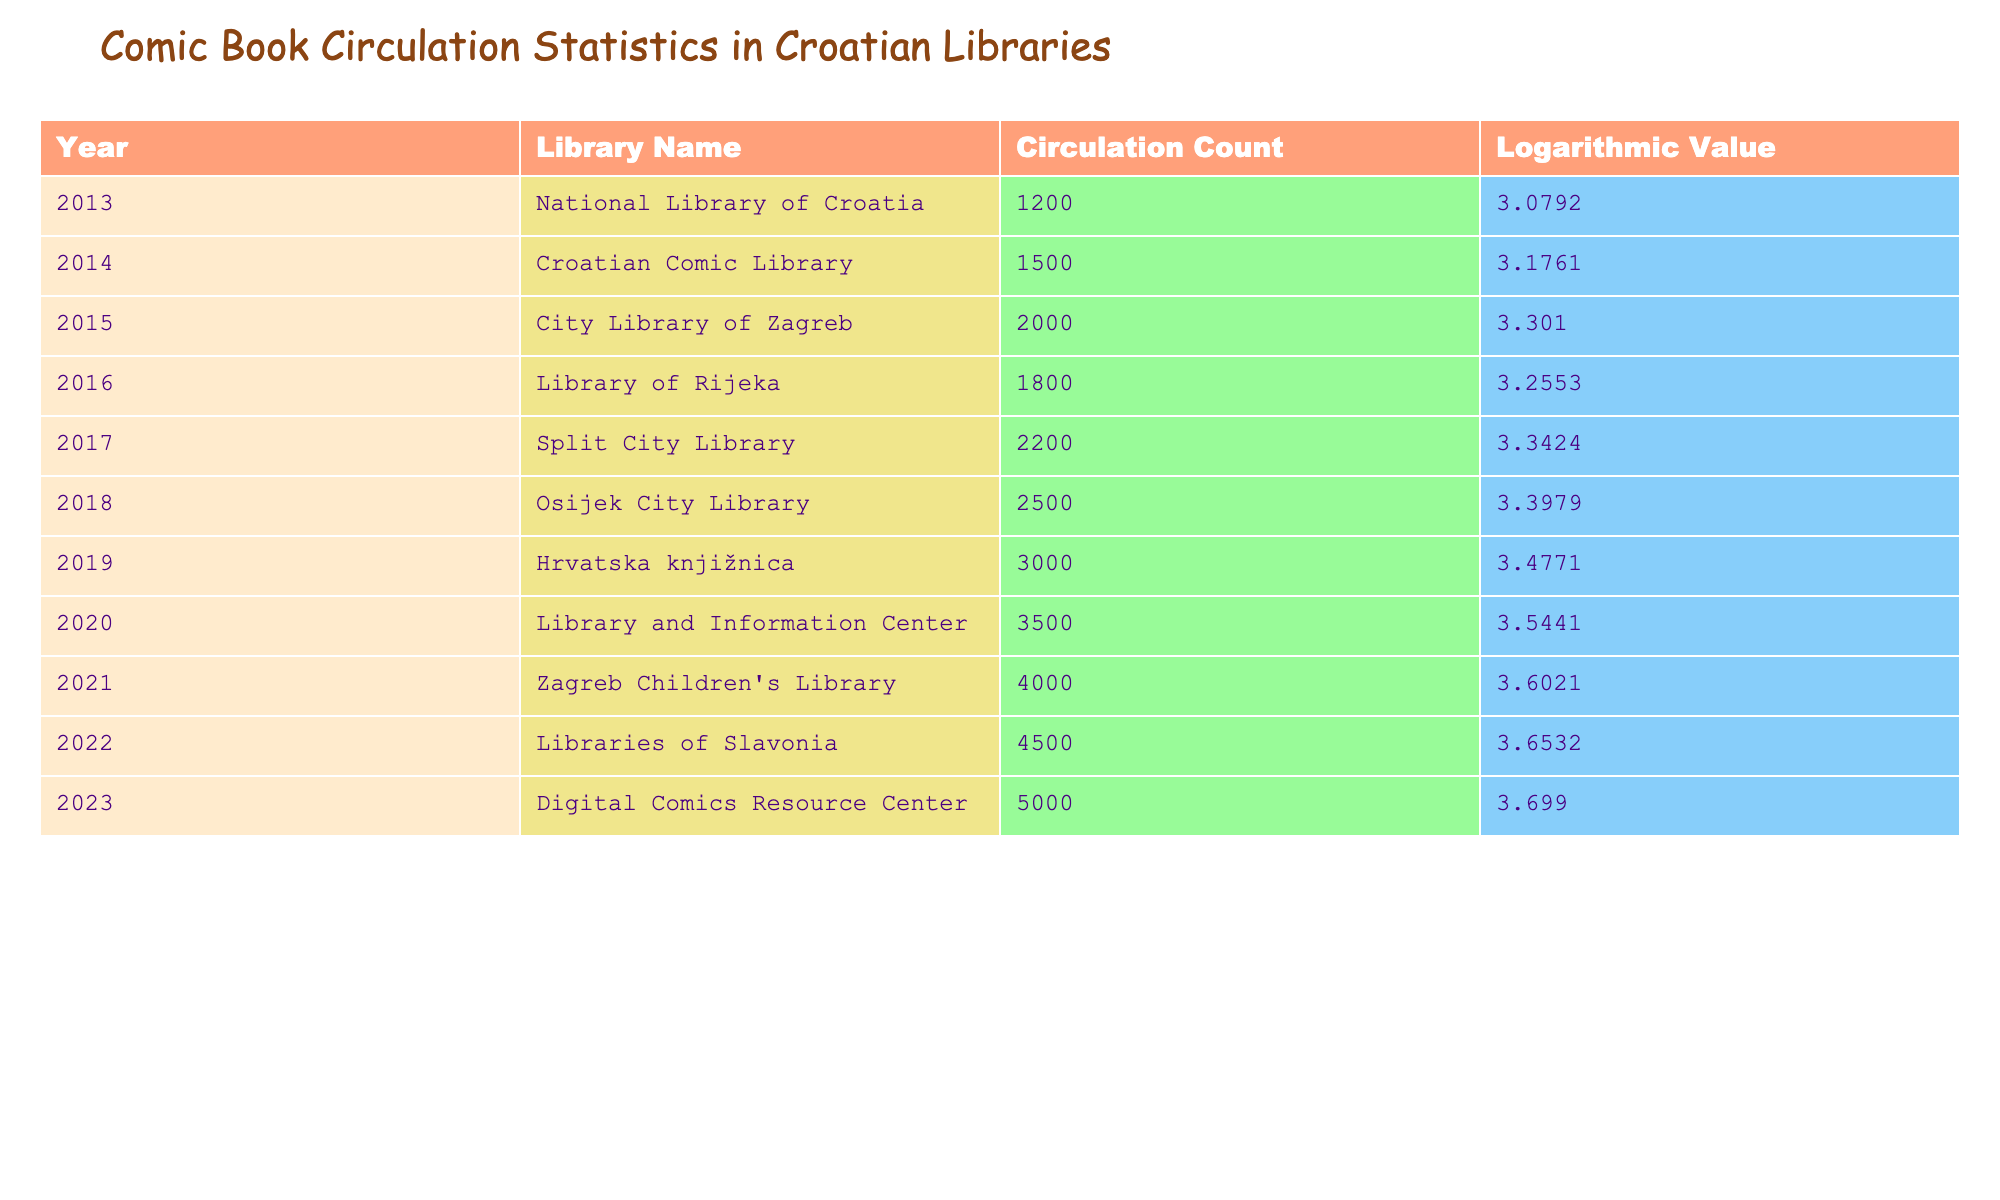What was the circulation count for the National Library of Croatia in 2013? The table shows that in 2013, the circulation count for the National Library of Croatia was recorded as 1200.
Answer: 1200 Which library had the highest circulation count in 2022? According to the table, the library with the highest circulation count in 2022 was the Libraries of Slavonia, with a count of 4500.
Answer: Libraries of Slavonia What is the difference in circulation count between 2020 and 2021? From the table, the circulation count in 2020 was 3500 and in 2021 it was 4000. The difference is calculated as 4000 - 3500 = 500.
Answer: 500 Was there a year where the circulation count decreased compared to the previous year? By examining the values in the table, it is evident that the circulation counts for each year consistently increased from 2013 to 2023 with no decreases.
Answer: No What was the average circulation count over the last decade? To find the average, we sum the circulation counts from 2013 to 2023: (1200 + 1500 + 2000 + 1800 + 2200 + 2500 + 3000 + 3500 + 4000 + 4500 + 5000) = 22500. There are 11 years, so the average is 22500/11 = 2045.45.
Answer: 2045.45 What was the logarithmic value for the circulation count in 2015? The table indicates that the logarithmic value for the circulation count in 2015 was 3.3010.
Answer: 3.3010 Which year had a circulation count of 3000? The table records a circulation count of 3000 in the year 2019.
Answer: 2019 How much did the circulation count increase from 2014 to 2018? The circulation count in 2014 was 1500 and in 2018 it was 2500. The increase can be calculated as 2500 - 1500 = 1000.
Answer: 1000 What are the circulation counts for the City Library of Zagreb and the Digital Comics Resource Center? The table shows that the circulation count for the City Library of Zagreb in 2015 was 2000, while the Digital Comics Resource Center in 2023 had a count of 5000.
Answer: 2000 and 5000 